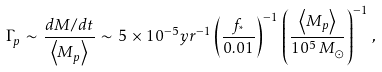<formula> <loc_0><loc_0><loc_500><loc_500>\Gamma _ { p } \, \sim \, \frac { d M / d t } { \left \langle M _ { p } \right \rangle } \, \sim \, 5 \, \times \, 1 0 ^ { - 5 } y r ^ { - 1 } \left ( \frac { f _ { ^ { * } } } { 0 . 0 1 } \right ) ^ { - 1 } \, \left ( \frac { \left \langle M _ { p } \right \rangle } { 1 0 ^ { 5 } \, M _ { \odot } } \right ) ^ { - 1 } \, ,</formula> 